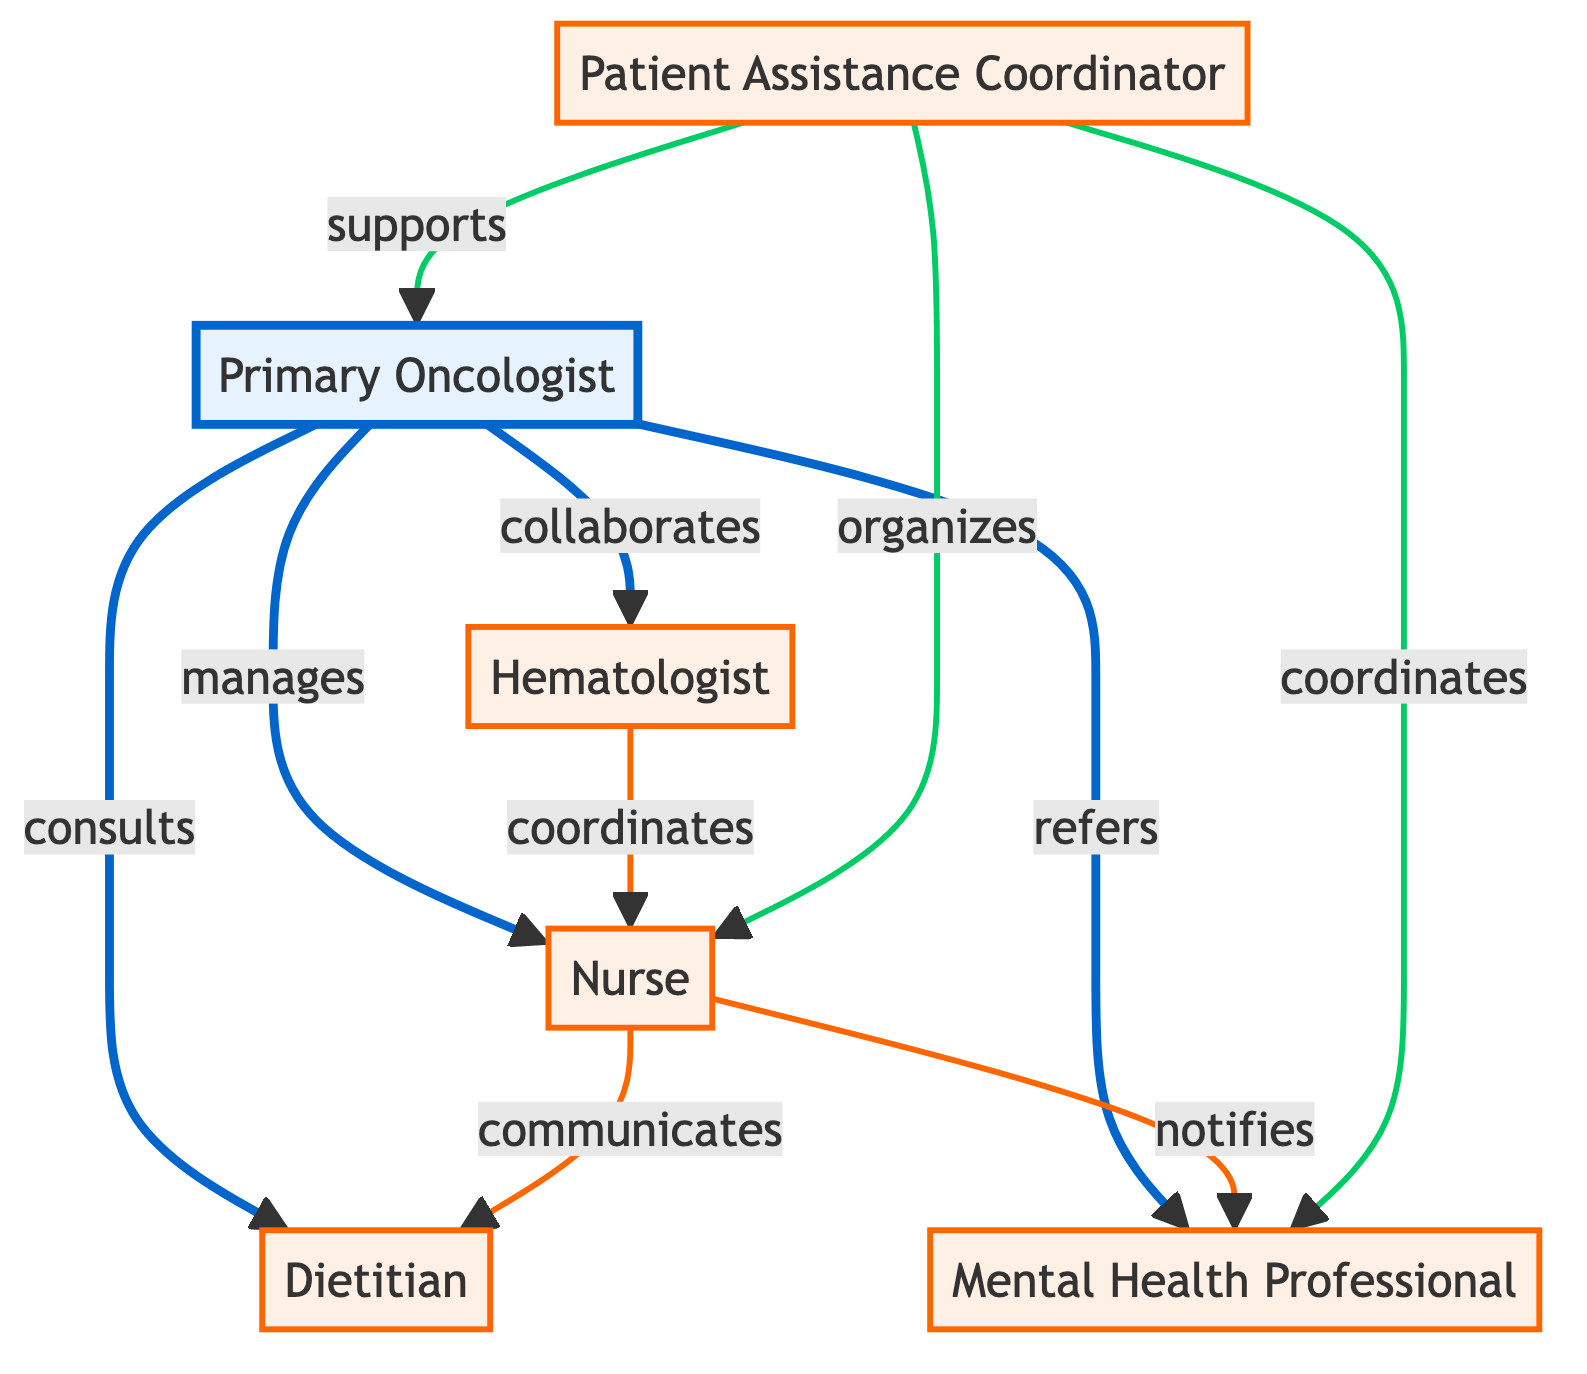What is the role of the Primary Oncologist? The Primary Oncologist oversees the cancer treatment plan and coordinates with other specialists, which is specified in the node description.
Answer: Oversees cancer treatment plan and coordinates with other specialists How many nodes are represented in the diagram? The diagram has six nodes each representing a distinct part of the healthcare team, which can be counted directly from the node list.
Answer: 6 Which two roles collaborate closely according to the diagram? The diagram specifies that the Primary Oncologist and Hematologist collaborate closely, as indicated by the edge type "collaborates" between these nodes.
Answer: Primary Oncologist and Hematologist What does the Nurse do in relation to the Dietitian? The Nurse communicates with the Dietitian to inform them of the patient's health, which is shown in the edge connecting these nodes with the description "informs."
Answer: Communicates Who refers the patient to the Mental Health Professional? The Primary Oncologist refers the patient to the Mental Health Professional, as stated in the edge description "refers" connecting these two nodes.
Answer: Primary Oncologist How does the Patient Assistance Coordinator support the nursing staff? The Patient Assistance Coordinator organizes logistical tasks related to scheduling and follow-ups for the nurses, as detailed in the edge description between these nodes.
Answer: Organizes In what way does the Hematologist interact with the Nurse? The Hematologist coordinates with the Nurse to monitor the patient's blood condition and treatment response, identified by the edge type "coordinates" in the diagram.
Answer: Coordinates Which role is involved in both supporting the Primary Oncologist and coordinating with the Mental Health Professional? The Patient Assistance Coordinator is involved in both supporting the Primary Oncologist and coordinating with the Mental Health Professional, as shown by two connections with distinct edge types.
Answer: Patient Assistance Coordinator 